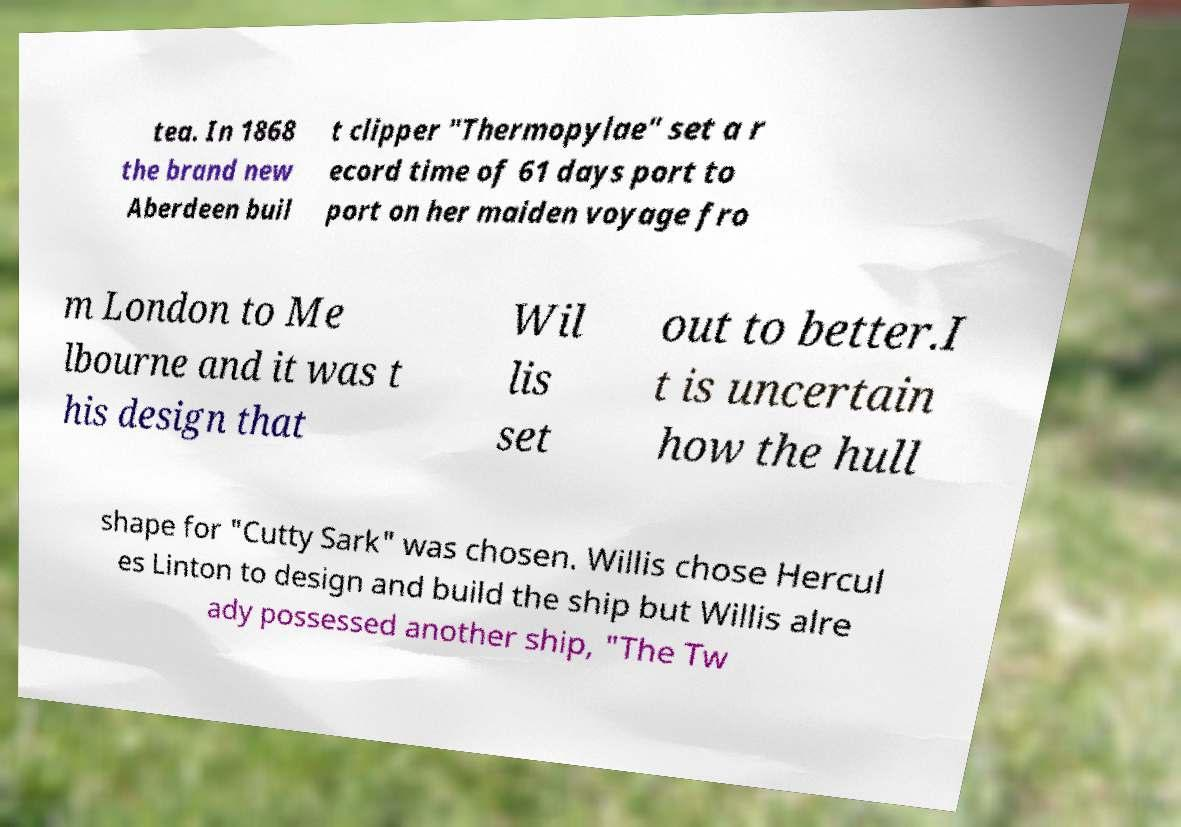I need the written content from this picture converted into text. Can you do that? tea. In 1868 the brand new Aberdeen buil t clipper "Thermopylae" set a r ecord time of 61 days port to port on her maiden voyage fro m London to Me lbourne and it was t his design that Wil lis set out to better.I t is uncertain how the hull shape for "Cutty Sark" was chosen. Willis chose Hercul es Linton to design and build the ship but Willis alre ady possessed another ship, "The Tw 